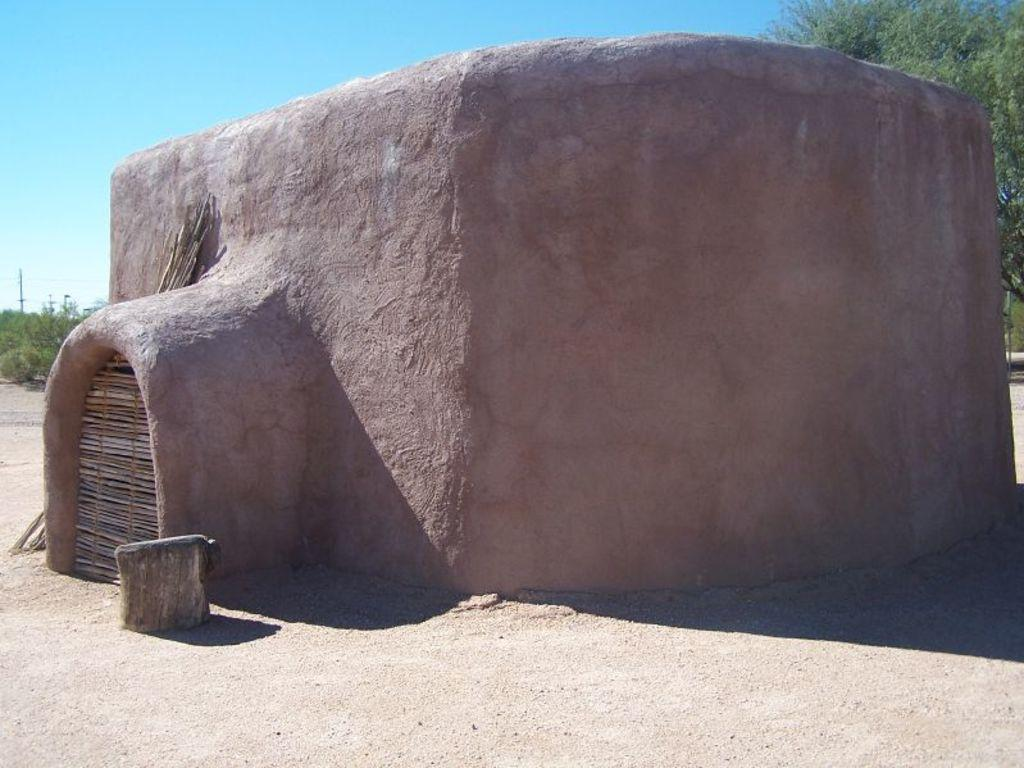What is the main structure in the center of the image? There is a house in the center of the image. What type of terrain is at the bottom of the image? There is sand at the bottom of the image. What can be seen in the background of the image? There are trees and the sky visible in the background of the image. What type of science experiment is being conducted in the image? There is no indication of a science experiment in the image; it features a house, sand, trees, and the sky. How many oranges are visible in the image? There are no oranges present in the image. 